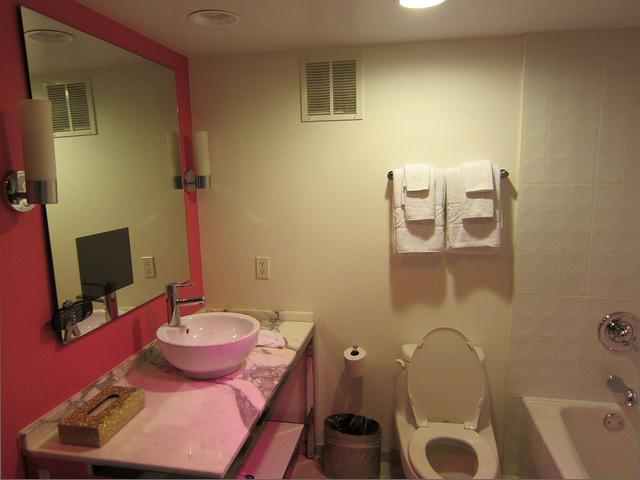What electronic device is embedded within the bathroom mirror in this bathroom? television 